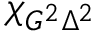Convert formula to latex. <formula><loc_0><loc_0><loc_500><loc_500>\chi _ { G ^ { 2 } \Delta ^ { 2 } }</formula> 